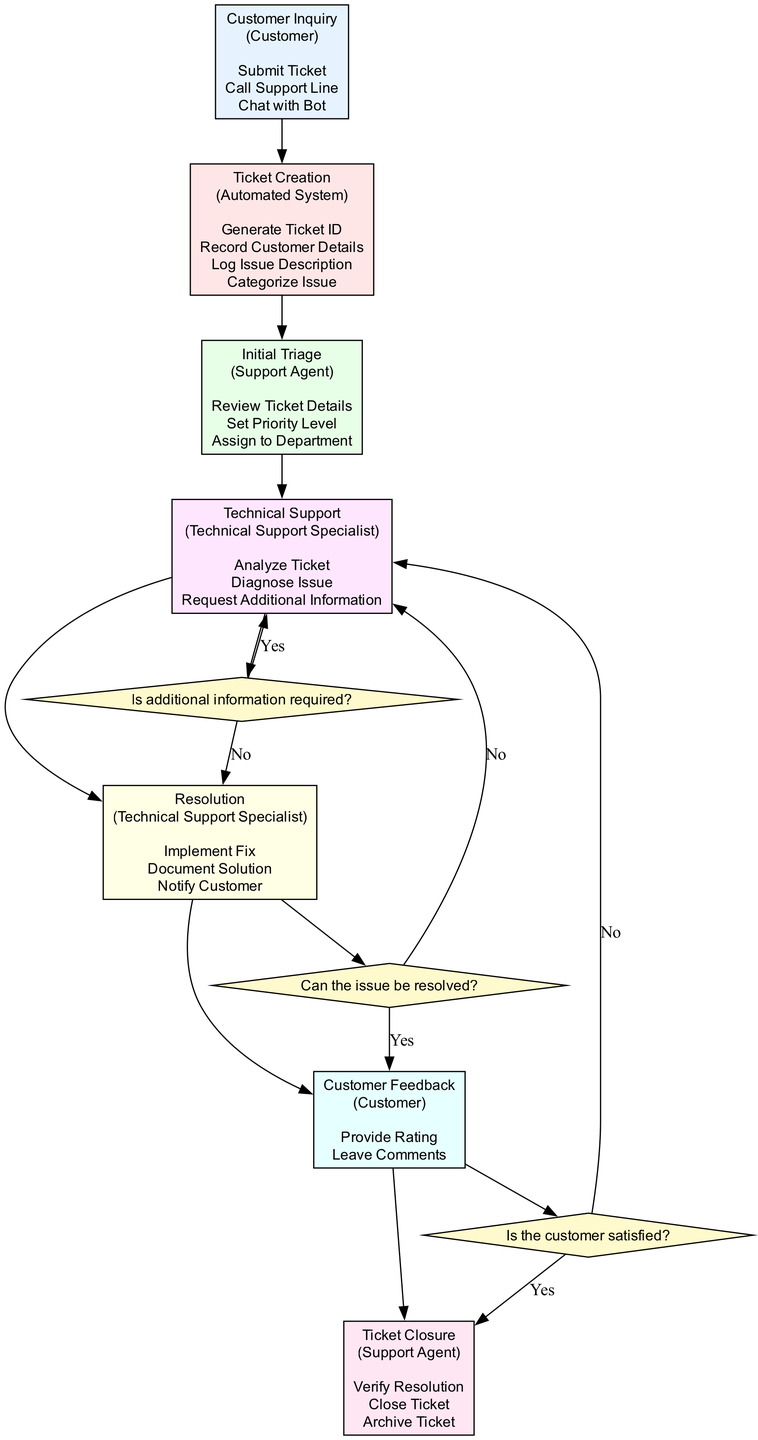What is the initial step in the customer support workflow? The diagram indicates that the initial step is "Customer Inquiry," which is where the customer contacts support with an issue or question.
Answer: Customer Inquiry Who creates the support ticket in the system? The "Ticket Creation" block specifies that the "Automated System" is responsible for creating the support ticket, generating a Ticket ID and recording customer details.
Answer: Automated System How many decision points are there in the workflow? By examining the diagram, three decision points are noted: whether additional information is required, whether the issue can be resolved, and whether the customer is satisfied.
Answer: 3 What happens if the issue cannot be resolved? According to the diagram, if the issue cannot be resolved, the flow will proceed to "Technical Support" instead of moving forward to "Customer Feedback."
Answer: Technical Support Which role is associated with the "Resolution" block? The diagram shows that the "Technical Support Specialist" role is associated with the "Resolution" block, responsible for implementing a fix and notifying the customer.
Answer: Technical Support Specialist What are the actions involved in the "Initial Triage" phase? The "Initial Triage" block lists the actions "Review Ticket Details," "Set Priority Level," and "Assign to Department" performed by the support agent.
Answer: Review Ticket Details, Set Priority Level, Assign to Department What do customers do during the "Customer Feedback" phase? In the "Customer Feedback" block, customers are prompted to "Provide Rating" and "Leave Comments" regarding their level of satisfaction with the support received.
Answer: Provide Rating, Leave Comments If additional information is required, where does the workflow lead? The diagram details that if additional information is required at the "Technical Support" decision point, the workflow loops back to "Technical Support" for further analysis.
Answer: Technical Support What is the final step of the workflow indicated in the diagram? The diagram highlights the "Ticket Closure" block as the final step, where the support agent verifies resolution, closes, and archives the ticket.
Answer: Ticket Closure 